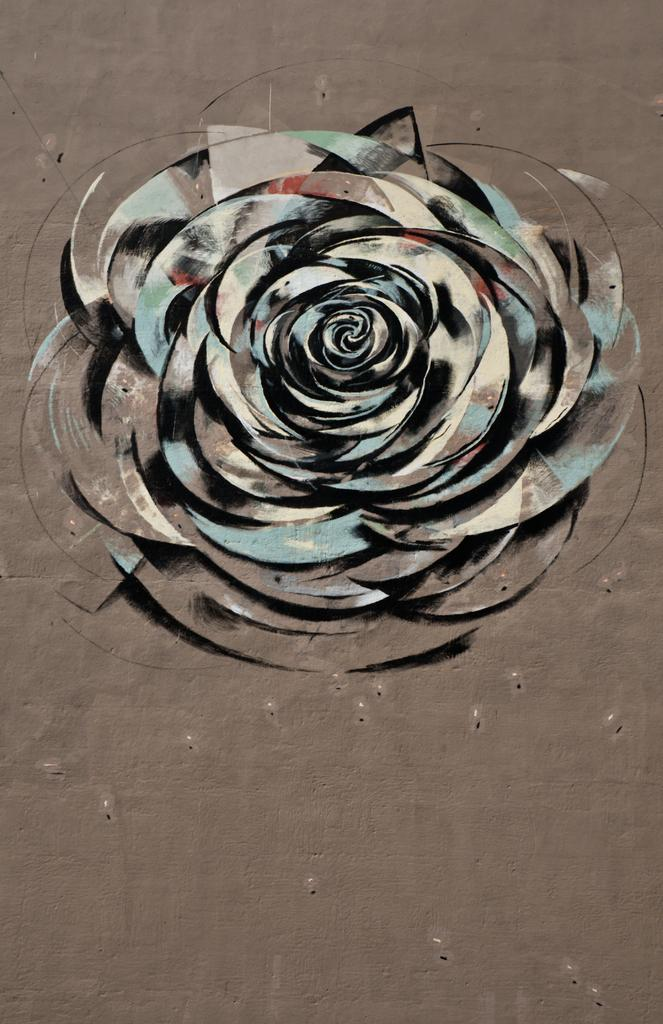What is the main subject of the painting in the foreground of the image? The main subject of the painting is a flower. What is the color of the surface on which the painting is placed? The painting is on a brown surface. What type of oven can be seen in the background of the image? There is no oven present in the image; it features a painting of a flower on a brown surface. What form does the flower in the painting take? The flower in the painting has a specific form, but it cannot be determined from the image alone. 